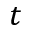Convert formula to latex. <formula><loc_0><loc_0><loc_500><loc_500>t</formula> 